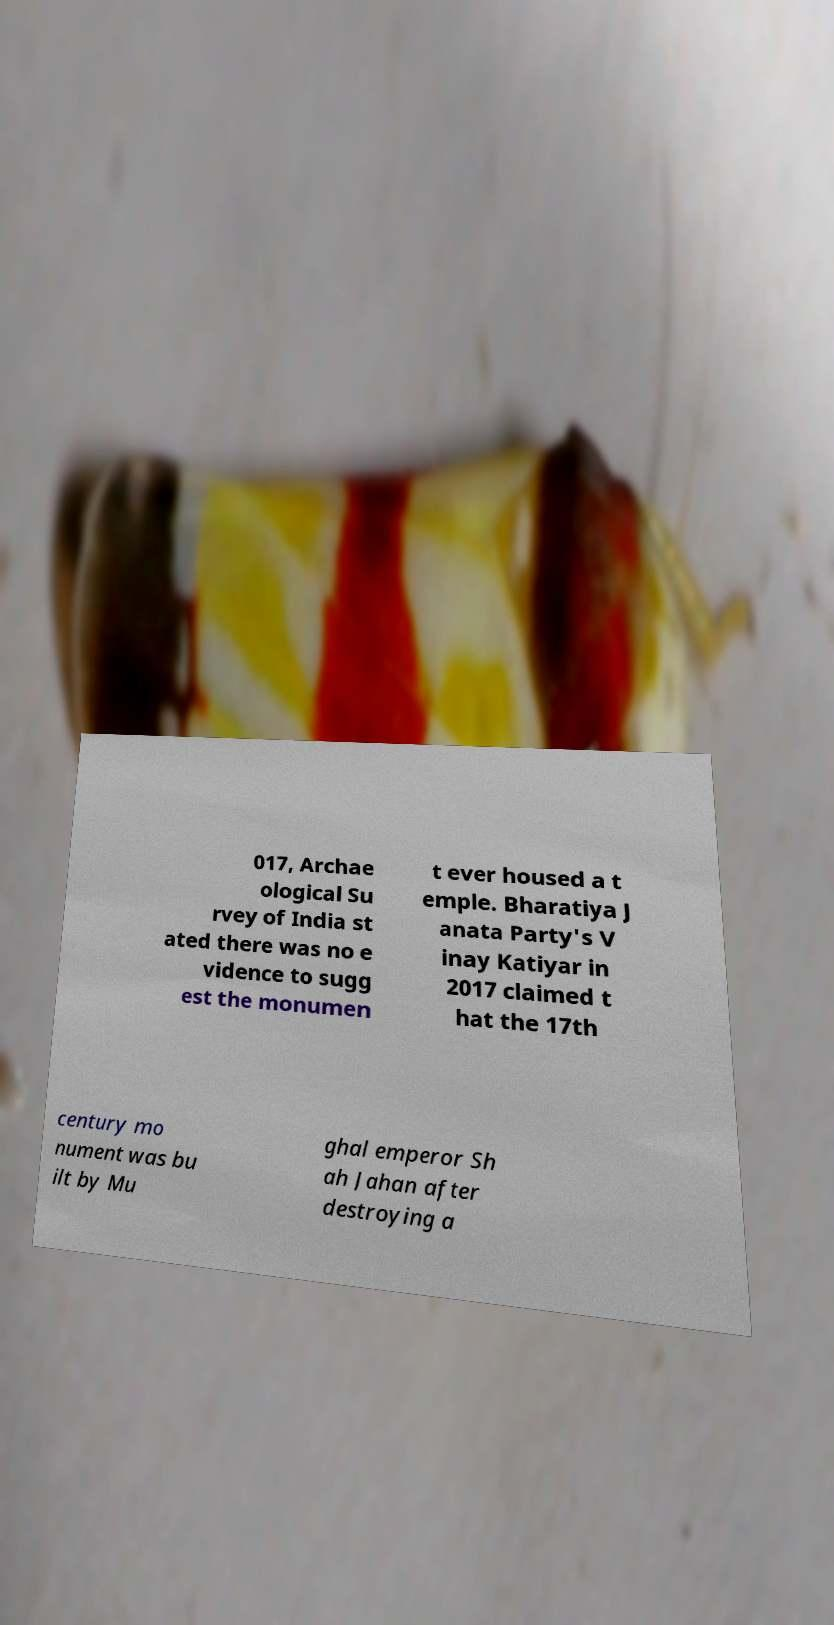I need the written content from this picture converted into text. Can you do that? 017, Archae ological Su rvey of India st ated there was no e vidence to sugg est the monumen t ever housed a t emple. Bharatiya J anata Party's V inay Katiyar in 2017 claimed t hat the 17th century mo nument was bu ilt by Mu ghal emperor Sh ah Jahan after destroying a 